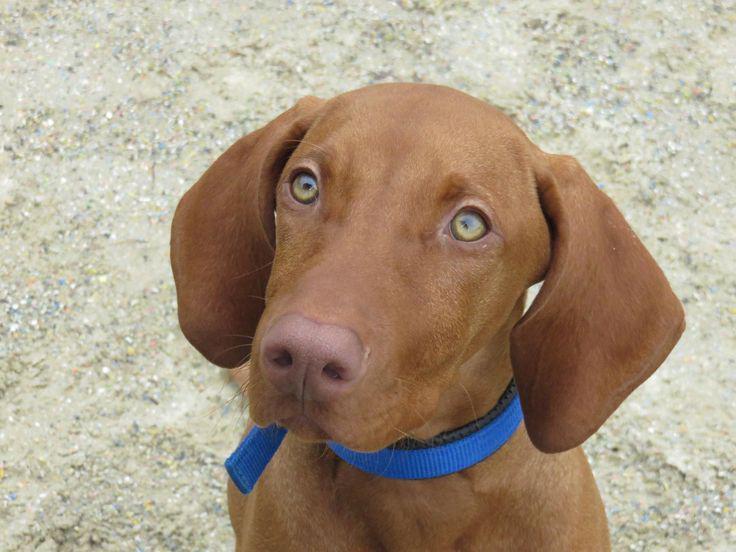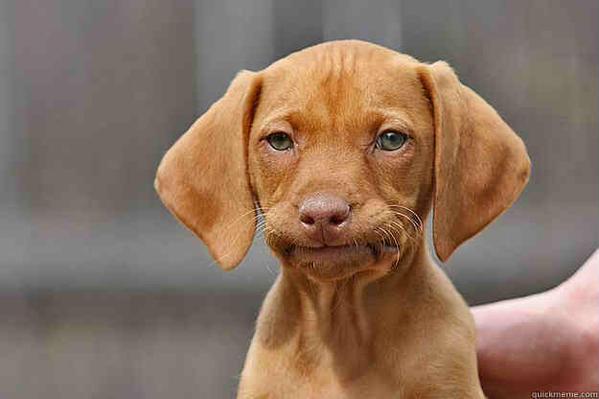The first image is the image on the left, the second image is the image on the right. Analyze the images presented: Is the assertion "The left image features a close-mouthed dog in a collar gazing up and to the left, and the right image features a puppy with a wrinkly mouth." valid? Answer yes or no. Yes. The first image is the image on the left, the second image is the image on the right. Analyze the images presented: Is the assertion "The dog on the left is wearing a brightly colored, clearly visible collar, while the dog on the right is seemingly not wearing a collar or anything else around it's neck." valid? Answer yes or no. Yes. 